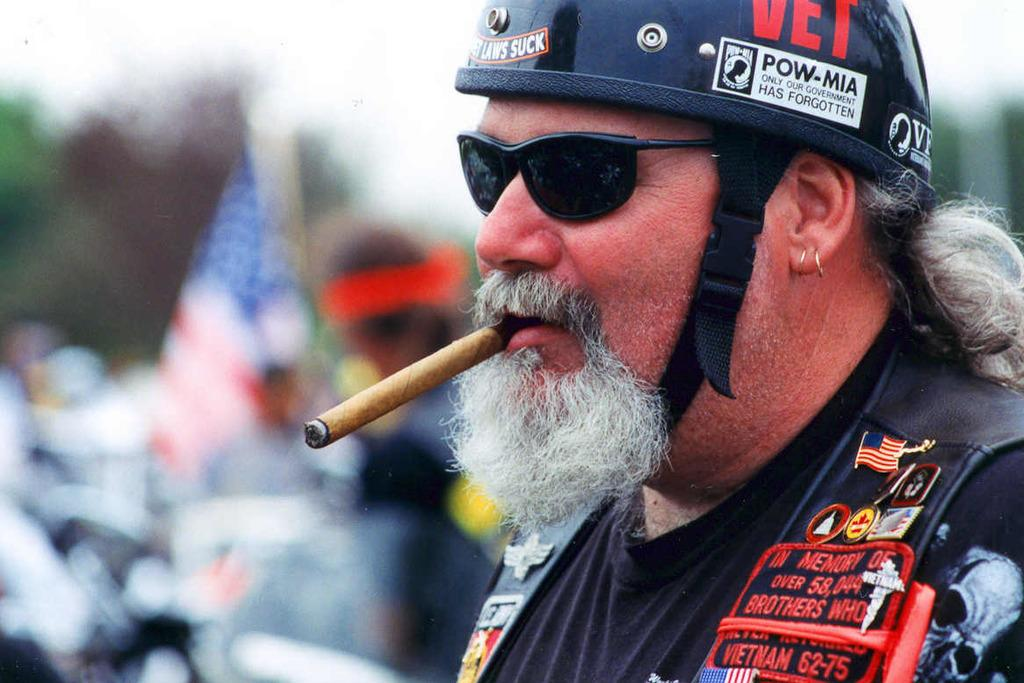What is the main subject of the image? There is a man in the image. What protective gear is the man wearing? The man is wearing a helmet and goggles. What activity might the man be engaged in, based on his attire? The man might be participating in an activity that requires protective gear, such as motorcycling or racing. What is the man doing with his hand in the image? The man is smoking a cigar. What can be seen in the background of the image? There is a flag and some objects in the background of the image. How would you describe the background of the image? The background is blurry. What type of circle is being drawn in the image? There is no circle being drawn in the image. What thought is the man having while smoking the cigar? It is impossible to determine the man's thoughts from the image alone. 